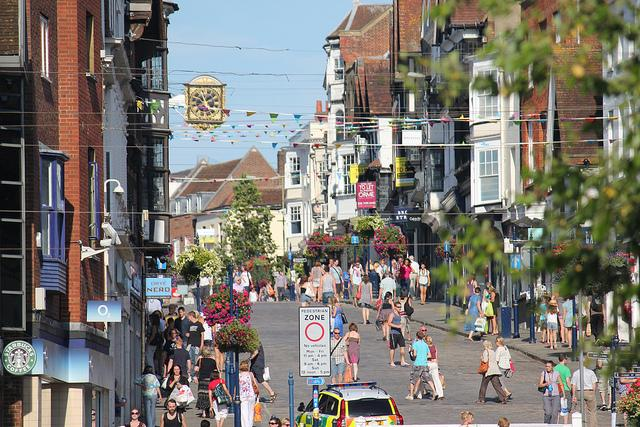What setting is this?

Choices:
A) desert
B) countryside
C) city
D) tundra city 